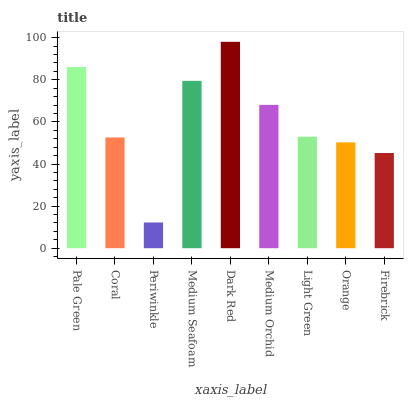Is Periwinkle the minimum?
Answer yes or no. Yes. Is Dark Red the maximum?
Answer yes or no. Yes. Is Coral the minimum?
Answer yes or no. No. Is Coral the maximum?
Answer yes or no. No. Is Pale Green greater than Coral?
Answer yes or no. Yes. Is Coral less than Pale Green?
Answer yes or no. Yes. Is Coral greater than Pale Green?
Answer yes or no. No. Is Pale Green less than Coral?
Answer yes or no. No. Is Light Green the high median?
Answer yes or no. Yes. Is Light Green the low median?
Answer yes or no. Yes. Is Medium Seafoam the high median?
Answer yes or no. No. Is Pale Green the low median?
Answer yes or no. No. 